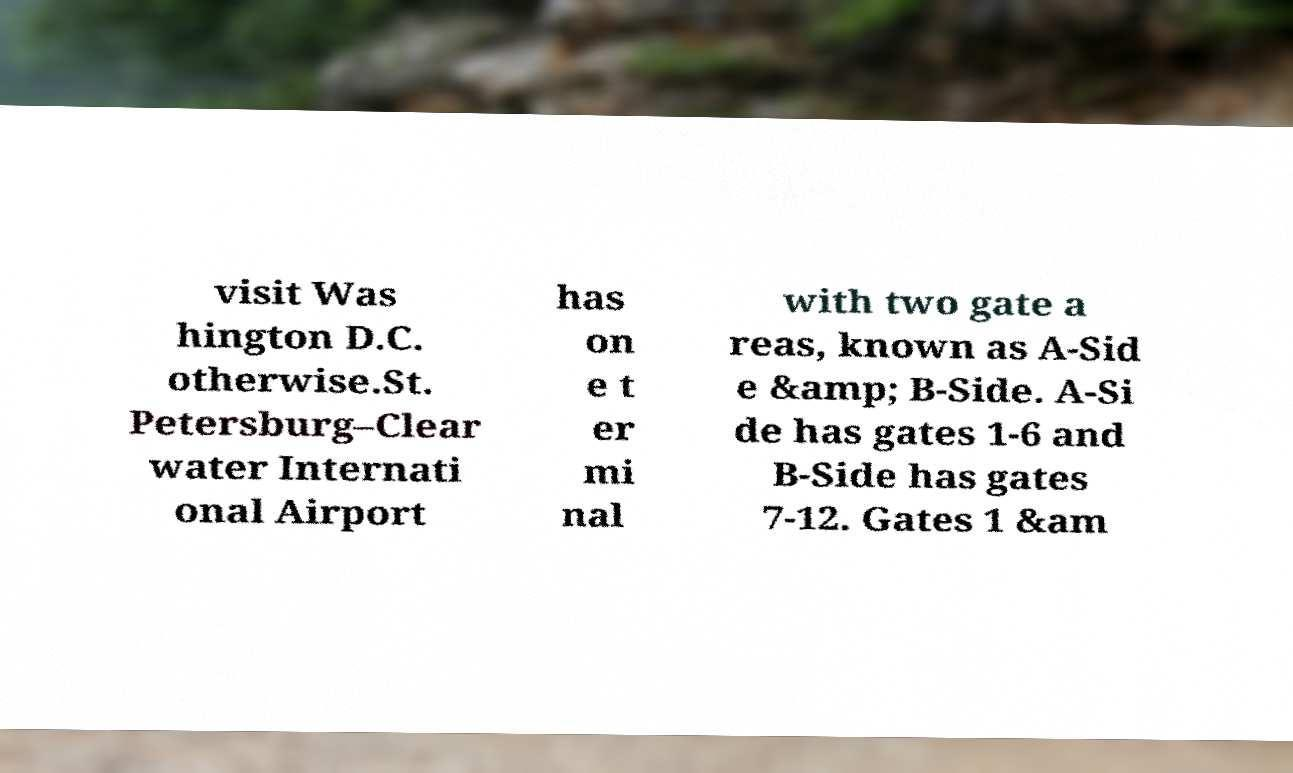Can you read and provide the text displayed in the image?This photo seems to have some interesting text. Can you extract and type it out for me? visit Was hington D.C. otherwise.St. Petersburg–Clear water Internati onal Airport has on e t er mi nal with two gate a reas, known as A-Sid e &amp; B-Side. A-Si de has gates 1-6 and B-Side has gates 7-12. Gates 1 &am 